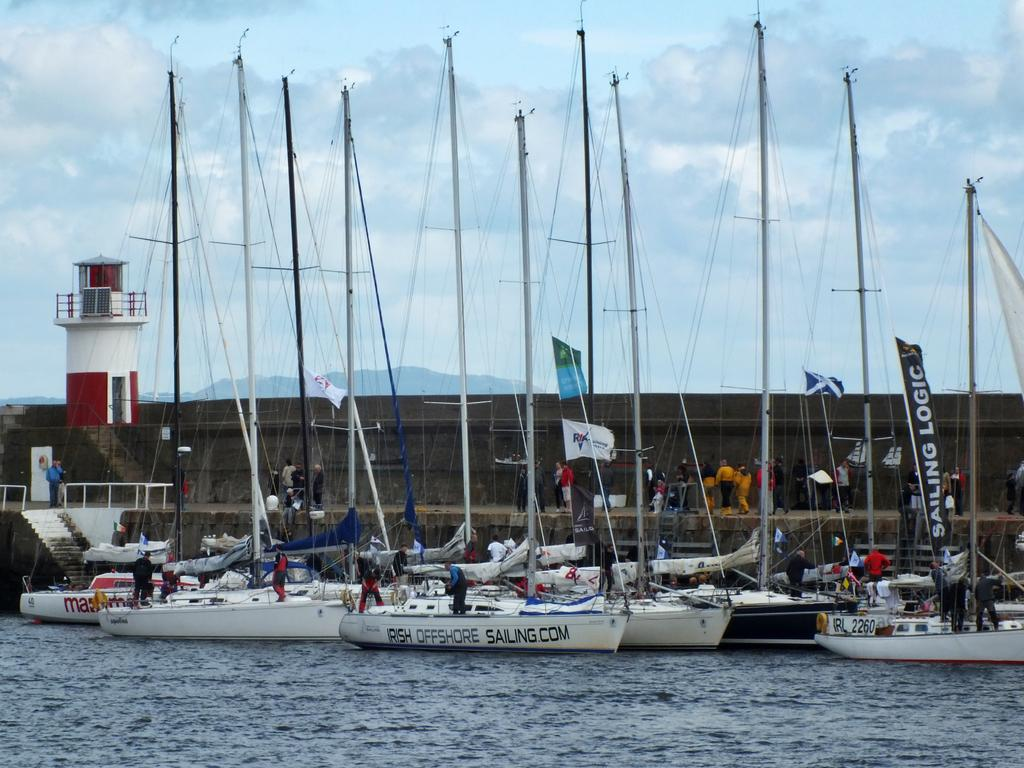Provide a one-sentence caption for the provided image. a boat with Irish Offshore sailing written on the side. 